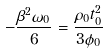<formula> <loc_0><loc_0><loc_500><loc_500>- \frac { \beta ^ { 2 } \omega _ { 0 } } { 6 } = \frac { \rho _ { 0 } t _ { 0 } ^ { 2 } } { 3 \phi _ { 0 } }</formula> 